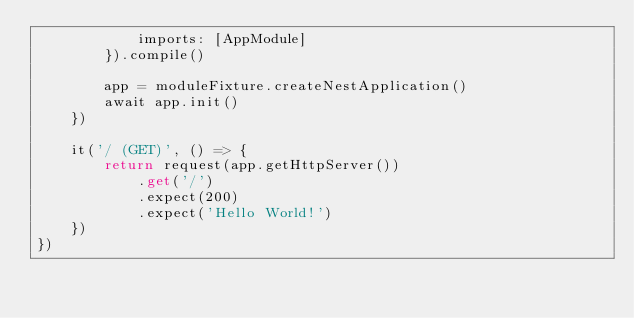<code> <loc_0><loc_0><loc_500><loc_500><_TypeScript_>            imports: [AppModule]
        }).compile()

        app = moduleFixture.createNestApplication()
        await app.init()
    })

    it('/ (GET)', () => {
        return request(app.getHttpServer())
            .get('/')
            .expect(200)
            .expect('Hello World!')
    })
})</code> 